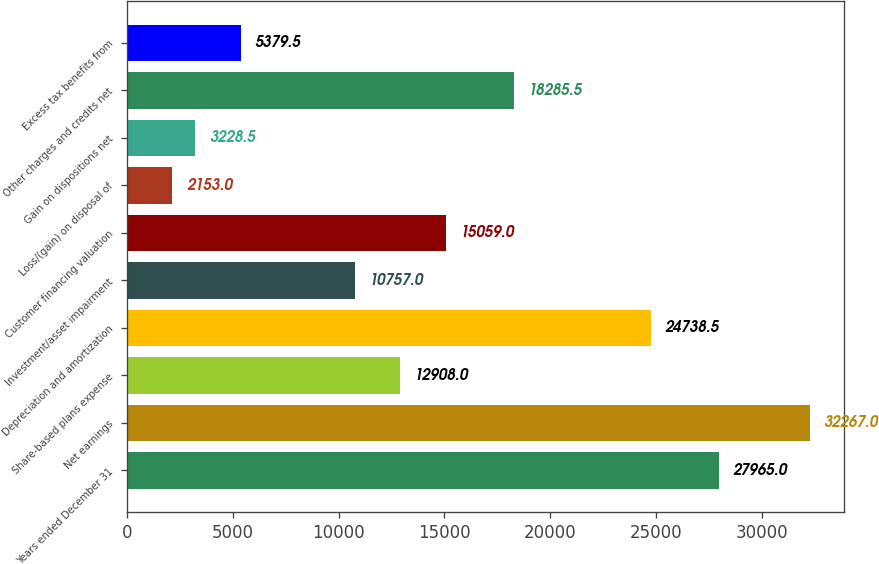<chart> <loc_0><loc_0><loc_500><loc_500><bar_chart><fcel>Years ended December 31<fcel>Net earnings<fcel>Share-based plans expense<fcel>Depreciation and amortization<fcel>Investment/asset impairment<fcel>Customer financing valuation<fcel>Loss/(gain) on disposal of<fcel>Gain on dispositions net<fcel>Other charges and credits net<fcel>Excess tax benefits from<nl><fcel>27965<fcel>32267<fcel>12908<fcel>24738.5<fcel>10757<fcel>15059<fcel>2153<fcel>3228.5<fcel>18285.5<fcel>5379.5<nl></chart> 